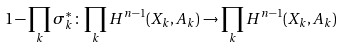<formula> <loc_0><loc_0><loc_500><loc_500>1 - \prod _ { k } \sigma _ { k } ^ { * } \colon \prod _ { k } H ^ { n - 1 } ( X _ { k } , A _ { k } ) \rightarrow \prod _ { k } H ^ { n - 1 } ( X _ { k } , A _ { k } )</formula> 